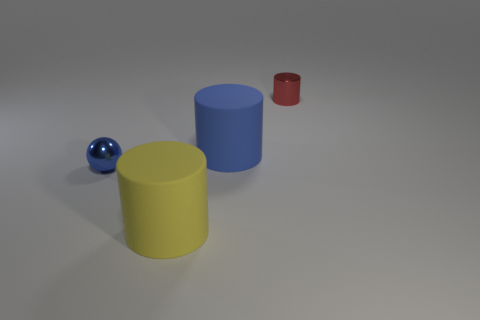There is a matte cylinder in front of the blue matte cylinder behind the yellow rubber cylinder; is there a large blue object that is left of it?
Your response must be concise. No. Is the number of tiny blue spheres greater than the number of tiny blue metallic cylinders?
Ensure brevity in your answer.  Yes. There is a big cylinder left of the blue rubber cylinder; what color is it?
Keep it short and to the point. Yellow. Are there more tiny metallic cylinders to the right of the small shiny cylinder than large red blocks?
Your answer should be compact. No. Do the large yellow cylinder and the tiny cylinder have the same material?
Offer a terse response. No. What number of other objects are there of the same shape as the large yellow thing?
Make the answer very short. 2. What is the color of the tiny object that is in front of the tiny object behind the large matte cylinder that is right of the big yellow cylinder?
Your response must be concise. Blue. There is a large rubber object that is behind the yellow cylinder; does it have the same shape as the big yellow rubber object?
Keep it short and to the point. Yes. How many tiny blue shiny spheres are there?
Give a very brief answer. 1. How many shiny objects have the same size as the metal ball?
Your answer should be compact. 1. 